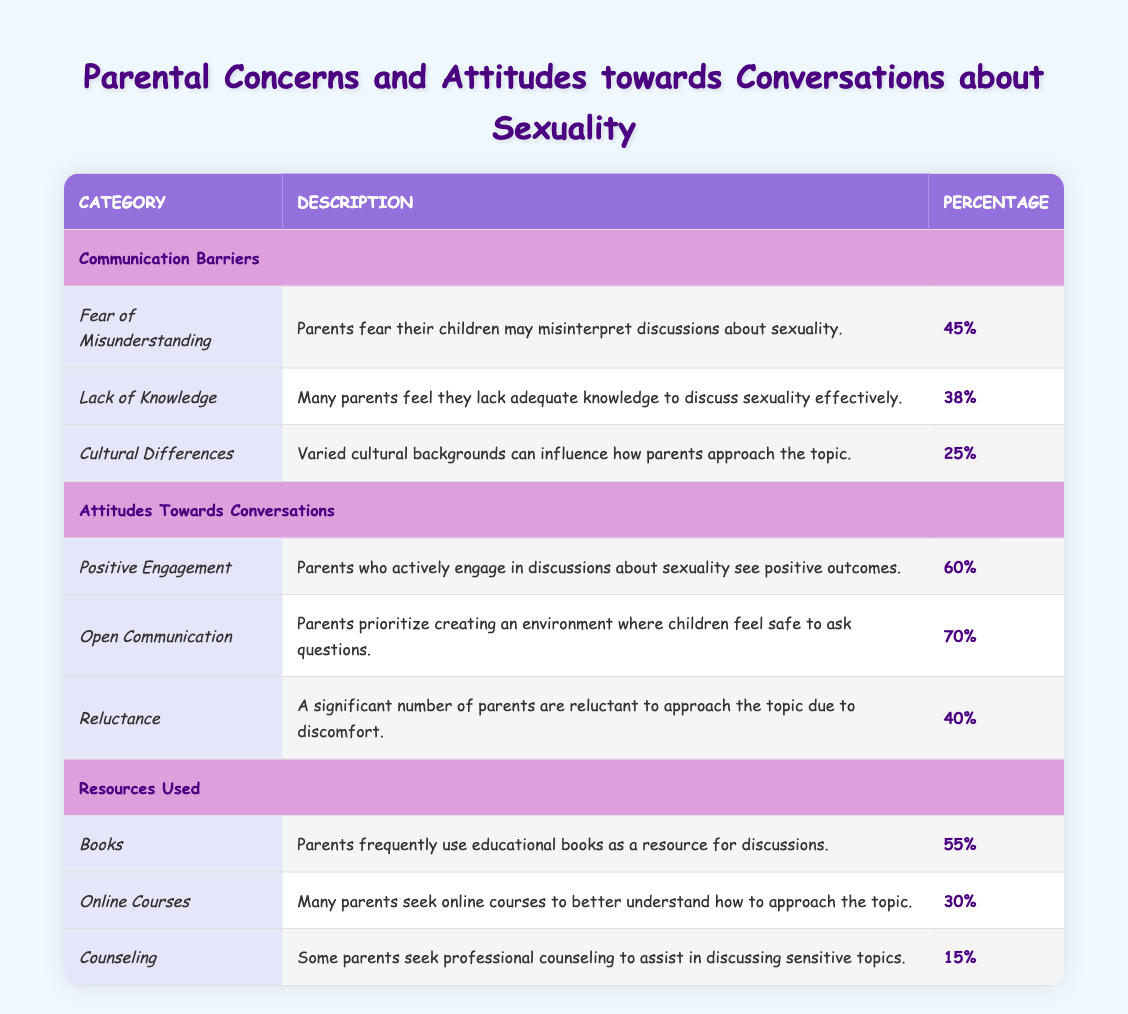What percentage of parents feel a lack of knowledge to discuss sexuality effectively? The table indicates that 38% of parents feel they lack adequate knowledge to discuss sexuality effectively. This is found under the "Lack of Knowledge" row in the "Communication Barriers" section.
Answer: 38% Which concern has the highest percentage among parents? The highest percentage among the concerns listed in the "Communication Barriers" is 45% for "Fear of Misunderstanding." This can be observed by comparing the percentages under that category.
Answer: Fear of Misunderstanding Is it true that more than half of parents use books as a resource for discussions? Yes, it is true because the table shows that 55% of parents frequently use educational books as a resource for discussions, which is greater than 50%.
Answer: Yes What is the average percentage of parents showing positive engagement and open communication? To find the average, add the percentages for "Positive Engagement" (60%) and "Open Communication" (70%), which totals 130%. Then, divide by the number of entries (2): 130% / 2 = 65%.
Answer: 65% Are parents more likely to engage in positive discussions about sexuality than to feel reluctant about them? Yes, parents are more likely to engage in positive discussions since 60% show positive engagement compared to 40% who feel reluctant. This comparison shows that the percentage of positive engagement is greater.
Answer: Yes What percentage of parents seek professional counseling for discussions about sensitive topics? According to the table, 15% of parents seek professional counseling to assist in discussing sensitive topics. This is specifically noted under the "Resources Used" category.
Answer: 15% Which category has the lowest overall concern percentage listed in the table? The "Cultural Differences" concern has the lowest percentage at 25% compared to other concerns in the "Communication Barriers" section. This can be verified by checking the values listed.
Answer: Cultural Differences How many parents prioritize creating an environment for open communication, as indicated in the table? 70% of parents prioritize creating an environment where children feel safe to ask questions, which is noted under the "Open Communication" row in the "Attitudes Towards Conversations" section.
Answer: 70% What is the difference between the percentage of parents who engage positively with their children and those who feel discomfort in discussing sexuality? To find the difference, subtract the percentage of reluctant parents (40%) from those who engage positively (60%): 60% - 40% = 20%.
Answer: 20% 